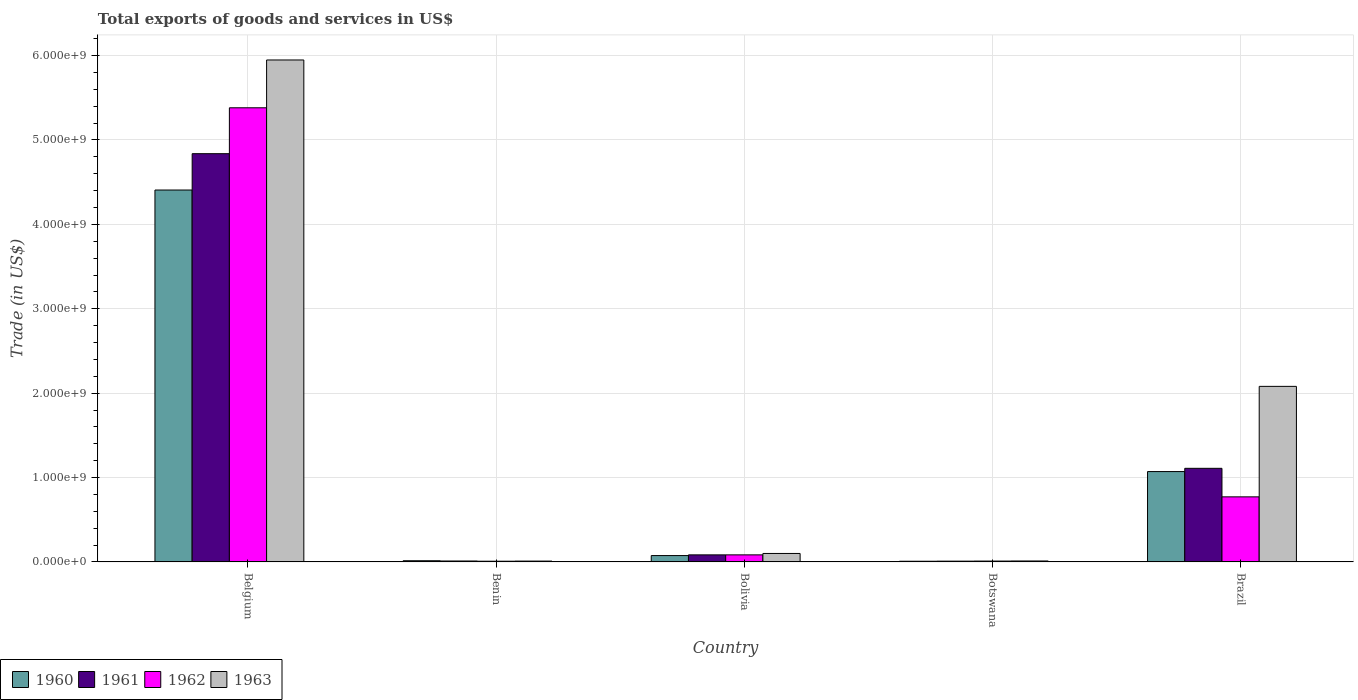How many different coloured bars are there?
Your answer should be very brief. 4. How many groups of bars are there?
Your answer should be very brief. 5. What is the label of the 4th group of bars from the left?
Your answer should be compact. Botswana. What is the total exports of goods and services in 1963 in Botswana?
Ensure brevity in your answer.  1.10e+07. Across all countries, what is the maximum total exports of goods and services in 1960?
Keep it short and to the point. 4.41e+09. Across all countries, what is the minimum total exports of goods and services in 1963?
Your answer should be very brief. 9.70e+06. In which country was the total exports of goods and services in 1962 maximum?
Provide a succinct answer. Belgium. In which country was the total exports of goods and services in 1962 minimum?
Ensure brevity in your answer.  Benin. What is the total total exports of goods and services in 1961 in the graph?
Your answer should be very brief. 6.05e+09. What is the difference between the total exports of goods and services in 1961 in Belgium and that in Botswana?
Ensure brevity in your answer.  4.83e+09. What is the difference between the total exports of goods and services in 1960 in Brazil and the total exports of goods and services in 1961 in Bolivia?
Make the answer very short. 9.87e+08. What is the average total exports of goods and services in 1962 per country?
Give a very brief answer. 1.25e+09. What is the difference between the total exports of goods and services of/in 1962 and total exports of goods and services of/in 1963 in Botswana?
Give a very brief answer. -1.09e+06. In how many countries, is the total exports of goods and services in 1960 greater than 1000000000 US$?
Provide a short and direct response. 2. What is the ratio of the total exports of goods and services in 1961 in Benin to that in Botswana?
Provide a succinct answer. 1.21. Is the difference between the total exports of goods and services in 1962 in Benin and Botswana greater than the difference between the total exports of goods and services in 1963 in Benin and Botswana?
Offer a terse response. No. What is the difference between the highest and the second highest total exports of goods and services in 1963?
Give a very brief answer. -5.85e+09. What is the difference between the highest and the lowest total exports of goods and services in 1962?
Give a very brief answer. 5.37e+09. In how many countries, is the total exports of goods and services in 1961 greater than the average total exports of goods and services in 1961 taken over all countries?
Offer a very short reply. 1. Is the sum of the total exports of goods and services in 1960 in Belgium and Bolivia greater than the maximum total exports of goods and services in 1963 across all countries?
Keep it short and to the point. No. Is it the case that in every country, the sum of the total exports of goods and services in 1961 and total exports of goods and services in 1962 is greater than the sum of total exports of goods and services in 1960 and total exports of goods and services in 1963?
Give a very brief answer. No. What does the 4th bar from the left in Bolivia represents?
Give a very brief answer. 1963. What does the 4th bar from the right in Belgium represents?
Keep it short and to the point. 1960. Is it the case that in every country, the sum of the total exports of goods and services in 1960 and total exports of goods and services in 1961 is greater than the total exports of goods and services in 1962?
Provide a succinct answer. Yes. Are all the bars in the graph horizontal?
Your answer should be compact. No. How many countries are there in the graph?
Offer a very short reply. 5. Are the values on the major ticks of Y-axis written in scientific E-notation?
Keep it short and to the point. Yes. Does the graph contain grids?
Ensure brevity in your answer.  Yes. How many legend labels are there?
Your response must be concise. 4. How are the legend labels stacked?
Provide a succinct answer. Horizontal. What is the title of the graph?
Make the answer very short. Total exports of goods and services in US$. What is the label or title of the X-axis?
Keep it short and to the point. Country. What is the label or title of the Y-axis?
Provide a succinct answer. Trade (in US$). What is the Trade (in US$) of 1960 in Belgium?
Offer a very short reply. 4.41e+09. What is the Trade (in US$) in 1961 in Belgium?
Your answer should be compact. 4.84e+09. What is the Trade (in US$) in 1962 in Belgium?
Your response must be concise. 5.38e+09. What is the Trade (in US$) of 1963 in Belgium?
Offer a terse response. 5.95e+09. What is the Trade (in US$) in 1960 in Benin?
Give a very brief answer. 1.39e+07. What is the Trade (in US$) of 1961 in Benin?
Your response must be concise. 1.08e+07. What is the Trade (in US$) of 1962 in Benin?
Provide a short and direct response. 8.32e+06. What is the Trade (in US$) of 1963 in Benin?
Your answer should be very brief. 9.70e+06. What is the Trade (in US$) of 1960 in Bolivia?
Make the answer very short. 7.51e+07. What is the Trade (in US$) in 1961 in Bolivia?
Ensure brevity in your answer.  8.35e+07. What is the Trade (in US$) in 1962 in Bolivia?
Give a very brief answer. 8.35e+07. What is the Trade (in US$) of 1963 in Bolivia?
Your answer should be very brief. 1.00e+08. What is the Trade (in US$) in 1960 in Botswana?
Ensure brevity in your answer.  7.99e+06. What is the Trade (in US$) in 1961 in Botswana?
Give a very brief answer. 8.95e+06. What is the Trade (in US$) in 1962 in Botswana?
Provide a short and direct response. 9.95e+06. What is the Trade (in US$) of 1963 in Botswana?
Your response must be concise. 1.10e+07. What is the Trade (in US$) of 1960 in Brazil?
Provide a succinct answer. 1.07e+09. What is the Trade (in US$) in 1961 in Brazil?
Offer a very short reply. 1.11e+09. What is the Trade (in US$) in 1962 in Brazil?
Your answer should be very brief. 7.71e+08. What is the Trade (in US$) of 1963 in Brazil?
Your answer should be very brief. 2.08e+09. Across all countries, what is the maximum Trade (in US$) of 1960?
Provide a short and direct response. 4.41e+09. Across all countries, what is the maximum Trade (in US$) of 1961?
Your answer should be very brief. 4.84e+09. Across all countries, what is the maximum Trade (in US$) in 1962?
Keep it short and to the point. 5.38e+09. Across all countries, what is the maximum Trade (in US$) in 1963?
Your answer should be compact. 5.95e+09. Across all countries, what is the minimum Trade (in US$) of 1960?
Your answer should be very brief. 7.99e+06. Across all countries, what is the minimum Trade (in US$) of 1961?
Your response must be concise. 8.95e+06. Across all countries, what is the minimum Trade (in US$) of 1962?
Ensure brevity in your answer.  8.32e+06. Across all countries, what is the minimum Trade (in US$) of 1963?
Ensure brevity in your answer.  9.70e+06. What is the total Trade (in US$) of 1960 in the graph?
Offer a terse response. 5.57e+09. What is the total Trade (in US$) of 1961 in the graph?
Offer a terse response. 6.05e+09. What is the total Trade (in US$) of 1962 in the graph?
Make the answer very short. 6.25e+09. What is the total Trade (in US$) in 1963 in the graph?
Ensure brevity in your answer.  8.15e+09. What is the difference between the Trade (in US$) of 1960 in Belgium and that in Benin?
Ensure brevity in your answer.  4.39e+09. What is the difference between the Trade (in US$) of 1961 in Belgium and that in Benin?
Ensure brevity in your answer.  4.83e+09. What is the difference between the Trade (in US$) of 1962 in Belgium and that in Benin?
Keep it short and to the point. 5.37e+09. What is the difference between the Trade (in US$) in 1963 in Belgium and that in Benin?
Your answer should be compact. 5.94e+09. What is the difference between the Trade (in US$) of 1960 in Belgium and that in Bolivia?
Keep it short and to the point. 4.33e+09. What is the difference between the Trade (in US$) in 1961 in Belgium and that in Bolivia?
Make the answer very short. 4.75e+09. What is the difference between the Trade (in US$) in 1962 in Belgium and that in Bolivia?
Ensure brevity in your answer.  5.30e+09. What is the difference between the Trade (in US$) of 1963 in Belgium and that in Bolivia?
Ensure brevity in your answer.  5.85e+09. What is the difference between the Trade (in US$) of 1960 in Belgium and that in Botswana?
Make the answer very short. 4.40e+09. What is the difference between the Trade (in US$) in 1961 in Belgium and that in Botswana?
Offer a very short reply. 4.83e+09. What is the difference between the Trade (in US$) in 1962 in Belgium and that in Botswana?
Keep it short and to the point. 5.37e+09. What is the difference between the Trade (in US$) of 1963 in Belgium and that in Botswana?
Make the answer very short. 5.94e+09. What is the difference between the Trade (in US$) in 1960 in Belgium and that in Brazil?
Make the answer very short. 3.34e+09. What is the difference between the Trade (in US$) of 1961 in Belgium and that in Brazil?
Your answer should be very brief. 3.73e+09. What is the difference between the Trade (in US$) in 1962 in Belgium and that in Brazil?
Your answer should be very brief. 4.61e+09. What is the difference between the Trade (in US$) of 1963 in Belgium and that in Brazil?
Provide a short and direct response. 3.87e+09. What is the difference between the Trade (in US$) in 1960 in Benin and that in Bolivia?
Make the answer very short. -6.13e+07. What is the difference between the Trade (in US$) of 1961 in Benin and that in Bolivia?
Give a very brief answer. -7.27e+07. What is the difference between the Trade (in US$) of 1962 in Benin and that in Bolivia?
Make the answer very short. -7.52e+07. What is the difference between the Trade (in US$) of 1963 in Benin and that in Bolivia?
Your answer should be compact. -9.05e+07. What is the difference between the Trade (in US$) of 1960 in Benin and that in Botswana?
Your response must be concise. 5.86e+06. What is the difference between the Trade (in US$) of 1961 in Benin and that in Botswana?
Your answer should be compact. 1.85e+06. What is the difference between the Trade (in US$) in 1962 in Benin and that in Botswana?
Your answer should be compact. -1.64e+06. What is the difference between the Trade (in US$) in 1963 in Benin and that in Botswana?
Your response must be concise. -1.34e+06. What is the difference between the Trade (in US$) of 1960 in Benin and that in Brazil?
Make the answer very short. -1.06e+09. What is the difference between the Trade (in US$) in 1961 in Benin and that in Brazil?
Your answer should be compact. -1.10e+09. What is the difference between the Trade (in US$) in 1962 in Benin and that in Brazil?
Your answer should be compact. -7.63e+08. What is the difference between the Trade (in US$) of 1963 in Benin and that in Brazil?
Make the answer very short. -2.07e+09. What is the difference between the Trade (in US$) in 1960 in Bolivia and that in Botswana?
Offer a terse response. 6.71e+07. What is the difference between the Trade (in US$) of 1961 in Bolivia and that in Botswana?
Your response must be concise. 7.45e+07. What is the difference between the Trade (in US$) in 1962 in Bolivia and that in Botswana?
Offer a terse response. 7.35e+07. What is the difference between the Trade (in US$) of 1963 in Bolivia and that in Botswana?
Your response must be concise. 8.91e+07. What is the difference between the Trade (in US$) of 1960 in Bolivia and that in Brazil?
Your response must be concise. -9.95e+08. What is the difference between the Trade (in US$) in 1961 in Bolivia and that in Brazil?
Provide a succinct answer. -1.03e+09. What is the difference between the Trade (in US$) in 1962 in Bolivia and that in Brazil?
Give a very brief answer. -6.87e+08. What is the difference between the Trade (in US$) of 1963 in Bolivia and that in Brazil?
Your answer should be very brief. -1.98e+09. What is the difference between the Trade (in US$) of 1960 in Botswana and that in Brazil?
Your answer should be very brief. -1.06e+09. What is the difference between the Trade (in US$) of 1961 in Botswana and that in Brazil?
Your response must be concise. -1.10e+09. What is the difference between the Trade (in US$) in 1962 in Botswana and that in Brazil?
Keep it short and to the point. -7.61e+08. What is the difference between the Trade (in US$) of 1963 in Botswana and that in Brazil?
Ensure brevity in your answer.  -2.07e+09. What is the difference between the Trade (in US$) in 1960 in Belgium and the Trade (in US$) in 1961 in Benin?
Provide a succinct answer. 4.40e+09. What is the difference between the Trade (in US$) of 1960 in Belgium and the Trade (in US$) of 1962 in Benin?
Your answer should be very brief. 4.40e+09. What is the difference between the Trade (in US$) in 1960 in Belgium and the Trade (in US$) in 1963 in Benin?
Make the answer very short. 4.40e+09. What is the difference between the Trade (in US$) in 1961 in Belgium and the Trade (in US$) in 1962 in Benin?
Provide a short and direct response. 4.83e+09. What is the difference between the Trade (in US$) in 1961 in Belgium and the Trade (in US$) in 1963 in Benin?
Your response must be concise. 4.83e+09. What is the difference between the Trade (in US$) in 1962 in Belgium and the Trade (in US$) in 1963 in Benin?
Ensure brevity in your answer.  5.37e+09. What is the difference between the Trade (in US$) of 1960 in Belgium and the Trade (in US$) of 1961 in Bolivia?
Your answer should be compact. 4.32e+09. What is the difference between the Trade (in US$) of 1960 in Belgium and the Trade (in US$) of 1962 in Bolivia?
Your answer should be compact. 4.32e+09. What is the difference between the Trade (in US$) of 1960 in Belgium and the Trade (in US$) of 1963 in Bolivia?
Your answer should be compact. 4.31e+09. What is the difference between the Trade (in US$) of 1961 in Belgium and the Trade (in US$) of 1962 in Bolivia?
Offer a terse response. 4.75e+09. What is the difference between the Trade (in US$) of 1961 in Belgium and the Trade (in US$) of 1963 in Bolivia?
Provide a succinct answer. 4.74e+09. What is the difference between the Trade (in US$) of 1962 in Belgium and the Trade (in US$) of 1963 in Bolivia?
Ensure brevity in your answer.  5.28e+09. What is the difference between the Trade (in US$) in 1960 in Belgium and the Trade (in US$) in 1961 in Botswana?
Provide a short and direct response. 4.40e+09. What is the difference between the Trade (in US$) in 1960 in Belgium and the Trade (in US$) in 1962 in Botswana?
Make the answer very short. 4.40e+09. What is the difference between the Trade (in US$) of 1960 in Belgium and the Trade (in US$) of 1963 in Botswana?
Ensure brevity in your answer.  4.40e+09. What is the difference between the Trade (in US$) in 1961 in Belgium and the Trade (in US$) in 1962 in Botswana?
Provide a short and direct response. 4.83e+09. What is the difference between the Trade (in US$) in 1961 in Belgium and the Trade (in US$) in 1963 in Botswana?
Give a very brief answer. 4.83e+09. What is the difference between the Trade (in US$) in 1962 in Belgium and the Trade (in US$) in 1963 in Botswana?
Your response must be concise. 5.37e+09. What is the difference between the Trade (in US$) of 1960 in Belgium and the Trade (in US$) of 1961 in Brazil?
Your answer should be very brief. 3.30e+09. What is the difference between the Trade (in US$) of 1960 in Belgium and the Trade (in US$) of 1962 in Brazil?
Ensure brevity in your answer.  3.64e+09. What is the difference between the Trade (in US$) in 1960 in Belgium and the Trade (in US$) in 1963 in Brazil?
Provide a short and direct response. 2.33e+09. What is the difference between the Trade (in US$) of 1961 in Belgium and the Trade (in US$) of 1962 in Brazil?
Your answer should be compact. 4.07e+09. What is the difference between the Trade (in US$) of 1961 in Belgium and the Trade (in US$) of 1963 in Brazil?
Your answer should be very brief. 2.76e+09. What is the difference between the Trade (in US$) in 1962 in Belgium and the Trade (in US$) in 1963 in Brazil?
Give a very brief answer. 3.30e+09. What is the difference between the Trade (in US$) of 1960 in Benin and the Trade (in US$) of 1961 in Bolivia?
Make the answer very short. -6.96e+07. What is the difference between the Trade (in US$) in 1960 in Benin and the Trade (in US$) in 1962 in Bolivia?
Provide a succinct answer. -6.96e+07. What is the difference between the Trade (in US$) in 1960 in Benin and the Trade (in US$) in 1963 in Bolivia?
Give a very brief answer. -8.63e+07. What is the difference between the Trade (in US$) in 1961 in Benin and the Trade (in US$) in 1962 in Bolivia?
Your answer should be compact. -7.27e+07. What is the difference between the Trade (in US$) in 1961 in Benin and the Trade (in US$) in 1963 in Bolivia?
Your response must be concise. -8.94e+07. What is the difference between the Trade (in US$) in 1962 in Benin and the Trade (in US$) in 1963 in Bolivia?
Keep it short and to the point. -9.19e+07. What is the difference between the Trade (in US$) of 1960 in Benin and the Trade (in US$) of 1961 in Botswana?
Your answer should be very brief. 4.90e+06. What is the difference between the Trade (in US$) of 1960 in Benin and the Trade (in US$) of 1962 in Botswana?
Provide a succinct answer. 3.90e+06. What is the difference between the Trade (in US$) of 1960 in Benin and the Trade (in US$) of 1963 in Botswana?
Make the answer very short. 2.81e+06. What is the difference between the Trade (in US$) of 1961 in Benin and the Trade (in US$) of 1962 in Botswana?
Give a very brief answer. 8.48e+05. What is the difference between the Trade (in US$) in 1961 in Benin and the Trade (in US$) in 1963 in Botswana?
Offer a terse response. -2.43e+05. What is the difference between the Trade (in US$) in 1962 in Benin and the Trade (in US$) in 1963 in Botswana?
Ensure brevity in your answer.  -2.73e+06. What is the difference between the Trade (in US$) of 1960 in Benin and the Trade (in US$) of 1961 in Brazil?
Provide a short and direct response. -1.10e+09. What is the difference between the Trade (in US$) of 1960 in Benin and the Trade (in US$) of 1962 in Brazil?
Provide a short and direct response. -7.57e+08. What is the difference between the Trade (in US$) in 1960 in Benin and the Trade (in US$) in 1963 in Brazil?
Make the answer very short. -2.07e+09. What is the difference between the Trade (in US$) of 1961 in Benin and the Trade (in US$) of 1962 in Brazil?
Provide a short and direct response. -7.60e+08. What is the difference between the Trade (in US$) in 1961 in Benin and the Trade (in US$) in 1963 in Brazil?
Ensure brevity in your answer.  -2.07e+09. What is the difference between the Trade (in US$) of 1962 in Benin and the Trade (in US$) of 1963 in Brazil?
Your response must be concise. -2.07e+09. What is the difference between the Trade (in US$) of 1960 in Bolivia and the Trade (in US$) of 1961 in Botswana?
Your answer should be very brief. 6.62e+07. What is the difference between the Trade (in US$) in 1960 in Bolivia and the Trade (in US$) in 1962 in Botswana?
Your answer should be very brief. 6.52e+07. What is the difference between the Trade (in US$) of 1960 in Bolivia and the Trade (in US$) of 1963 in Botswana?
Offer a very short reply. 6.41e+07. What is the difference between the Trade (in US$) in 1961 in Bolivia and the Trade (in US$) in 1962 in Botswana?
Your answer should be very brief. 7.35e+07. What is the difference between the Trade (in US$) in 1961 in Bolivia and the Trade (in US$) in 1963 in Botswana?
Ensure brevity in your answer.  7.24e+07. What is the difference between the Trade (in US$) of 1962 in Bolivia and the Trade (in US$) of 1963 in Botswana?
Make the answer very short. 7.24e+07. What is the difference between the Trade (in US$) of 1960 in Bolivia and the Trade (in US$) of 1961 in Brazil?
Your response must be concise. -1.03e+09. What is the difference between the Trade (in US$) in 1960 in Bolivia and the Trade (in US$) in 1962 in Brazil?
Your answer should be very brief. -6.96e+08. What is the difference between the Trade (in US$) of 1960 in Bolivia and the Trade (in US$) of 1963 in Brazil?
Give a very brief answer. -2.01e+09. What is the difference between the Trade (in US$) in 1961 in Bolivia and the Trade (in US$) in 1962 in Brazil?
Keep it short and to the point. -6.87e+08. What is the difference between the Trade (in US$) of 1961 in Bolivia and the Trade (in US$) of 1963 in Brazil?
Provide a succinct answer. -2.00e+09. What is the difference between the Trade (in US$) in 1962 in Bolivia and the Trade (in US$) in 1963 in Brazil?
Give a very brief answer. -2.00e+09. What is the difference between the Trade (in US$) of 1960 in Botswana and the Trade (in US$) of 1961 in Brazil?
Keep it short and to the point. -1.10e+09. What is the difference between the Trade (in US$) in 1960 in Botswana and the Trade (in US$) in 1962 in Brazil?
Your response must be concise. -7.63e+08. What is the difference between the Trade (in US$) of 1960 in Botswana and the Trade (in US$) of 1963 in Brazil?
Make the answer very short. -2.07e+09. What is the difference between the Trade (in US$) in 1961 in Botswana and the Trade (in US$) in 1962 in Brazil?
Offer a terse response. -7.62e+08. What is the difference between the Trade (in US$) of 1961 in Botswana and the Trade (in US$) of 1963 in Brazil?
Provide a succinct answer. -2.07e+09. What is the difference between the Trade (in US$) of 1962 in Botswana and the Trade (in US$) of 1963 in Brazil?
Offer a terse response. -2.07e+09. What is the average Trade (in US$) in 1960 per country?
Offer a very short reply. 1.11e+09. What is the average Trade (in US$) in 1961 per country?
Your response must be concise. 1.21e+09. What is the average Trade (in US$) of 1962 per country?
Your answer should be very brief. 1.25e+09. What is the average Trade (in US$) in 1963 per country?
Provide a short and direct response. 1.63e+09. What is the difference between the Trade (in US$) of 1960 and Trade (in US$) of 1961 in Belgium?
Provide a short and direct response. -4.31e+08. What is the difference between the Trade (in US$) in 1960 and Trade (in US$) in 1962 in Belgium?
Make the answer very short. -9.75e+08. What is the difference between the Trade (in US$) in 1960 and Trade (in US$) in 1963 in Belgium?
Provide a short and direct response. -1.54e+09. What is the difference between the Trade (in US$) of 1961 and Trade (in US$) of 1962 in Belgium?
Provide a short and direct response. -5.44e+08. What is the difference between the Trade (in US$) in 1961 and Trade (in US$) in 1963 in Belgium?
Make the answer very short. -1.11e+09. What is the difference between the Trade (in US$) in 1962 and Trade (in US$) in 1963 in Belgium?
Ensure brevity in your answer.  -5.67e+08. What is the difference between the Trade (in US$) in 1960 and Trade (in US$) in 1961 in Benin?
Ensure brevity in your answer.  3.05e+06. What is the difference between the Trade (in US$) in 1960 and Trade (in US$) in 1962 in Benin?
Offer a very short reply. 5.53e+06. What is the difference between the Trade (in US$) of 1960 and Trade (in US$) of 1963 in Benin?
Provide a succinct answer. 4.15e+06. What is the difference between the Trade (in US$) of 1961 and Trade (in US$) of 1962 in Benin?
Give a very brief answer. 2.48e+06. What is the difference between the Trade (in US$) of 1961 and Trade (in US$) of 1963 in Benin?
Your response must be concise. 1.10e+06. What is the difference between the Trade (in US$) in 1962 and Trade (in US$) in 1963 in Benin?
Your answer should be compact. -1.39e+06. What is the difference between the Trade (in US$) in 1960 and Trade (in US$) in 1961 in Bolivia?
Provide a succinct answer. -8.35e+06. What is the difference between the Trade (in US$) in 1960 and Trade (in US$) in 1962 in Bolivia?
Your answer should be compact. -8.35e+06. What is the difference between the Trade (in US$) of 1960 and Trade (in US$) of 1963 in Bolivia?
Keep it short and to the point. -2.50e+07. What is the difference between the Trade (in US$) in 1961 and Trade (in US$) in 1963 in Bolivia?
Provide a succinct answer. -1.67e+07. What is the difference between the Trade (in US$) in 1962 and Trade (in US$) in 1963 in Bolivia?
Your answer should be very brief. -1.67e+07. What is the difference between the Trade (in US$) in 1960 and Trade (in US$) in 1961 in Botswana?
Your answer should be compact. -9.64e+05. What is the difference between the Trade (in US$) of 1960 and Trade (in US$) of 1962 in Botswana?
Provide a succinct answer. -1.96e+06. What is the difference between the Trade (in US$) in 1960 and Trade (in US$) in 1963 in Botswana?
Your answer should be compact. -3.05e+06. What is the difference between the Trade (in US$) in 1961 and Trade (in US$) in 1962 in Botswana?
Offer a terse response. -9.99e+05. What is the difference between the Trade (in US$) in 1961 and Trade (in US$) in 1963 in Botswana?
Your answer should be compact. -2.09e+06. What is the difference between the Trade (in US$) of 1962 and Trade (in US$) of 1963 in Botswana?
Your answer should be very brief. -1.09e+06. What is the difference between the Trade (in US$) in 1960 and Trade (in US$) in 1961 in Brazil?
Make the answer very short. -3.86e+07. What is the difference between the Trade (in US$) of 1960 and Trade (in US$) of 1962 in Brazil?
Offer a terse response. 3.00e+08. What is the difference between the Trade (in US$) in 1960 and Trade (in US$) in 1963 in Brazil?
Provide a short and direct response. -1.01e+09. What is the difference between the Trade (in US$) in 1961 and Trade (in US$) in 1962 in Brazil?
Provide a succinct answer. 3.38e+08. What is the difference between the Trade (in US$) of 1961 and Trade (in US$) of 1963 in Brazil?
Offer a very short reply. -9.71e+08. What is the difference between the Trade (in US$) of 1962 and Trade (in US$) of 1963 in Brazil?
Offer a very short reply. -1.31e+09. What is the ratio of the Trade (in US$) of 1960 in Belgium to that in Benin?
Provide a succinct answer. 318.15. What is the ratio of the Trade (in US$) of 1961 in Belgium to that in Benin?
Provide a short and direct response. 447.86. What is the ratio of the Trade (in US$) in 1962 in Belgium to that in Benin?
Make the answer very short. 647.03. What is the ratio of the Trade (in US$) in 1963 in Belgium to that in Benin?
Give a very brief answer. 613. What is the ratio of the Trade (in US$) in 1960 in Belgium to that in Bolivia?
Keep it short and to the point. 58.66. What is the ratio of the Trade (in US$) of 1961 in Belgium to that in Bolivia?
Your response must be concise. 57.95. What is the ratio of the Trade (in US$) in 1962 in Belgium to that in Bolivia?
Give a very brief answer. 64.47. What is the ratio of the Trade (in US$) of 1963 in Belgium to that in Bolivia?
Give a very brief answer. 59.38. What is the ratio of the Trade (in US$) in 1960 in Belgium to that in Botswana?
Offer a terse response. 551.52. What is the ratio of the Trade (in US$) in 1961 in Belgium to that in Botswana?
Provide a short and direct response. 540.23. What is the ratio of the Trade (in US$) of 1962 in Belgium to that in Botswana?
Keep it short and to the point. 540.64. What is the ratio of the Trade (in US$) of 1963 in Belgium to that in Botswana?
Your response must be concise. 538.57. What is the ratio of the Trade (in US$) of 1960 in Belgium to that in Brazil?
Ensure brevity in your answer.  4.12. What is the ratio of the Trade (in US$) in 1961 in Belgium to that in Brazil?
Make the answer very short. 4.36. What is the ratio of the Trade (in US$) of 1962 in Belgium to that in Brazil?
Your response must be concise. 6.98. What is the ratio of the Trade (in US$) of 1963 in Belgium to that in Brazil?
Your answer should be very brief. 2.86. What is the ratio of the Trade (in US$) in 1960 in Benin to that in Bolivia?
Ensure brevity in your answer.  0.18. What is the ratio of the Trade (in US$) of 1961 in Benin to that in Bolivia?
Make the answer very short. 0.13. What is the ratio of the Trade (in US$) of 1962 in Benin to that in Bolivia?
Your response must be concise. 0.1. What is the ratio of the Trade (in US$) in 1963 in Benin to that in Bolivia?
Offer a terse response. 0.1. What is the ratio of the Trade (in US$) in 1960 in Benin to that in Botswana?
Ensure brevity in your answer.  1.73. What is the ratio of the Trade (in US$) of 1961 in Benin to that in Botswana?
Provide a short and direct response. 1.21. What is the ratio of the Trade (in US$) of 1962 in Benin to that in Botswana?
Provide a short and direct response. 0.84. What is the ratio of the Trade (in US$) of 1963 in Benin to that in Botswana?
Offer a terse response. 0.88. What is the ratio of the Trade (in US$) of 1960 in Benin to that in Brazil?
Offer a terse response. 0.01. What is the ratio of the Trade (in US$) in 1961 in Benin to that in Brazil?
Offer a terse response. 0.01. What is the ratio of the Trade (in US$) in 1962 in Benin to that in Brazil?
Give a very brief answer. 0.01. What is the ratio of the Trade (in US$) of 1963 in Benin to that in Brazil?
Your answer should be very brief. 0. What is the ratio of the Trade (in US$) of 1960 in Bolivia to that in Botswana?
Give a very brief answer. 9.4. What is the ratio of the Trade (in US$) of 1961 in Bolivia to that in Botswana?
Provide a succinct answer. 9.32. What is the ratio of the Trade (in US$) in 1962 in Bolivia to that in Botswana?
Give a very brief answer. 8.39. What is the ratio of the Trade (in US$) in 1963 in Bolivia to that in Botswana?
Your answer should be very brief. 9.07. What is the ratio of the Trade (in US$) of 1960 in Bolivia to that in Brazil?
Offer a terse response. 0.07. What is the ratio of the Trade (in US$) of 1961 in Bolivia to that in Brazil?
Your answer should be very brief. 0.08. What is the ratio of the Trade (in US$) of 1962 in Bolivia to that in Brazil?
Give a very brief answer. 0.11. What is the ratio of the Trade (in US$) in 1963 in Bolivia to that in Brazil?
Your response must be concise. 0.05. What is the ratio of the Trade (in US$) in 1960 in Botswana to that in Brazil?
Give a very brief answer. 0.01. What is the ratio of the Trade (in US$) of 1961 in Botswana to that in Brazil?
Give a very brief answer. 0.01. What is the ratio of the Trade (in US$) in 1962 in Botswana to that in Brazil?
Your response must be concise. 0.01. What is the ratio of the Trade (in US$) of 1963 in Botswana to that in Brazil?
Provide a short and direct response. 0.01. What is the difference between the highest and the second highest Trade (in US$) in 1960?
Provide a short and direct response. 3.34e+09. What is the difference between the highest and the second highest Trade (in US$) of 1961?
Give a very brief answer. 3.73e+09. What is the difference between the highest and the second highest Trade (in US$) in 1962?
Your answer should be compact. 4.61e+09. What is the difference between the highest and the second highest Trade (in US$) of 1963?
Give a very brief answer. 3.87e+09. What is the difference between the highest and the lowest Trade (in US$) of 1960?
Offer a terse response. 4.40e+09. What is the difference between the highest and the lowest Trade (in US$) of 1961?
Your response must be concise. 4.83e+09. What is the difference between the highest and the lowest Trade (in US$) in 1962?
Offer a very short reply. 5.37e+09. What is the difference between the highest and the lowest Trade (in US$) of 1963?
Your response must be concise. 5.94e+09. 